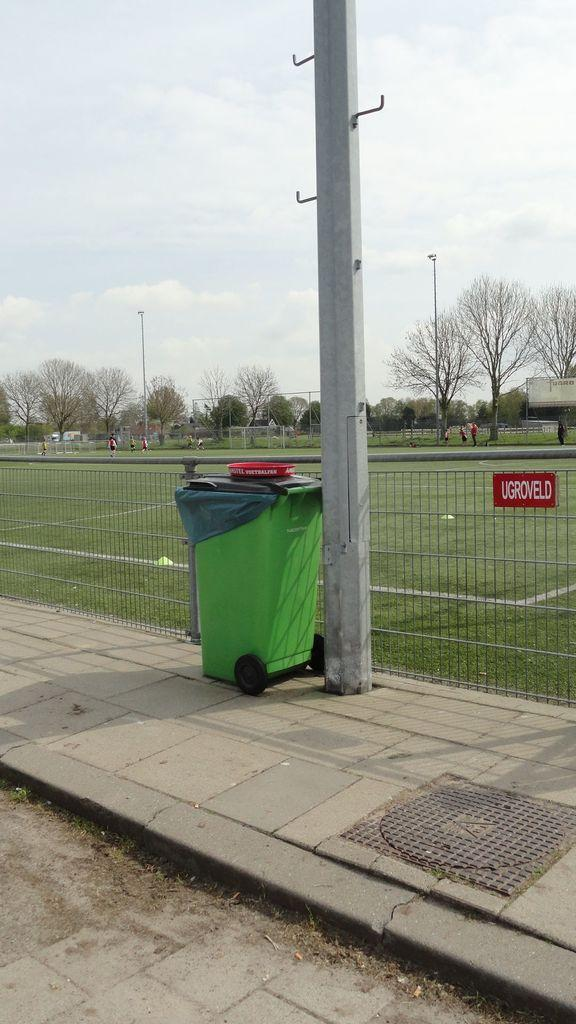What type of natural elements can be seen in the image? There are trees in the image. What man-made structures are present in the image? There are poles and fencing in the image. Are there any people in the image? Yes, there are people in the image. What type of receptacle is visible in the image? There is a dustbin in the image. What other objects can be seen in the image? There are other objects in the image, but their specific details are not mentioned in the facts. What is visible in the background of the image? The sky is visible in the image. What type of copper material can be seen in the image? There is no copper material present in the image. What are the people in the image cooking? The facts do not mention any cooking or food preparation in the image. 